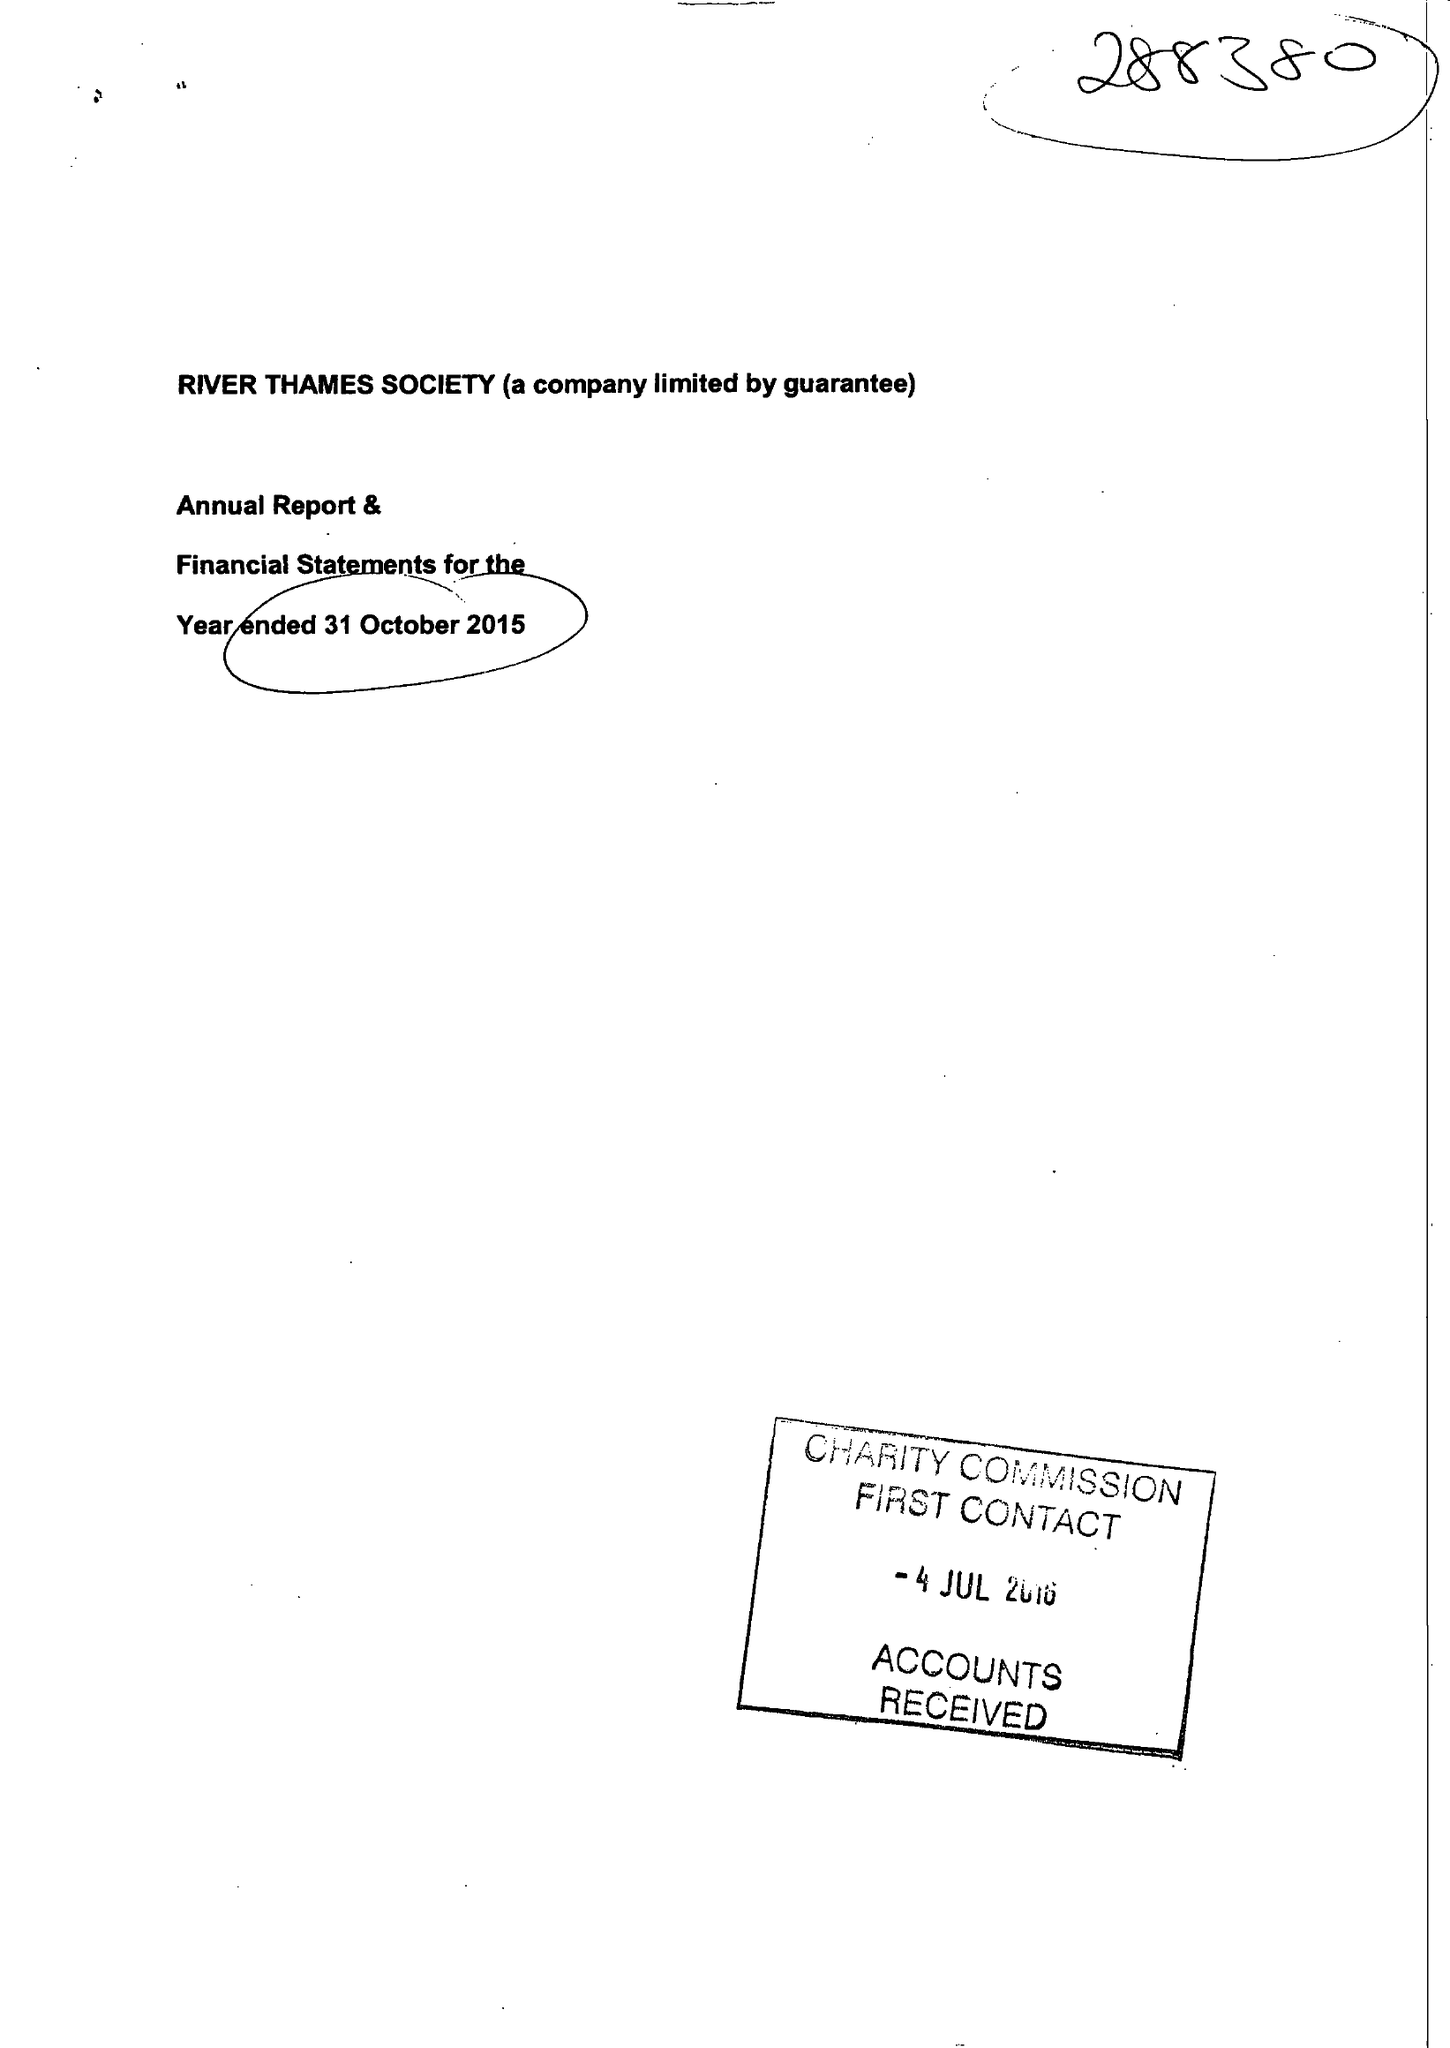What is the value for the report_date?
Answer the question using a single word or phrase. 2015-10-31 